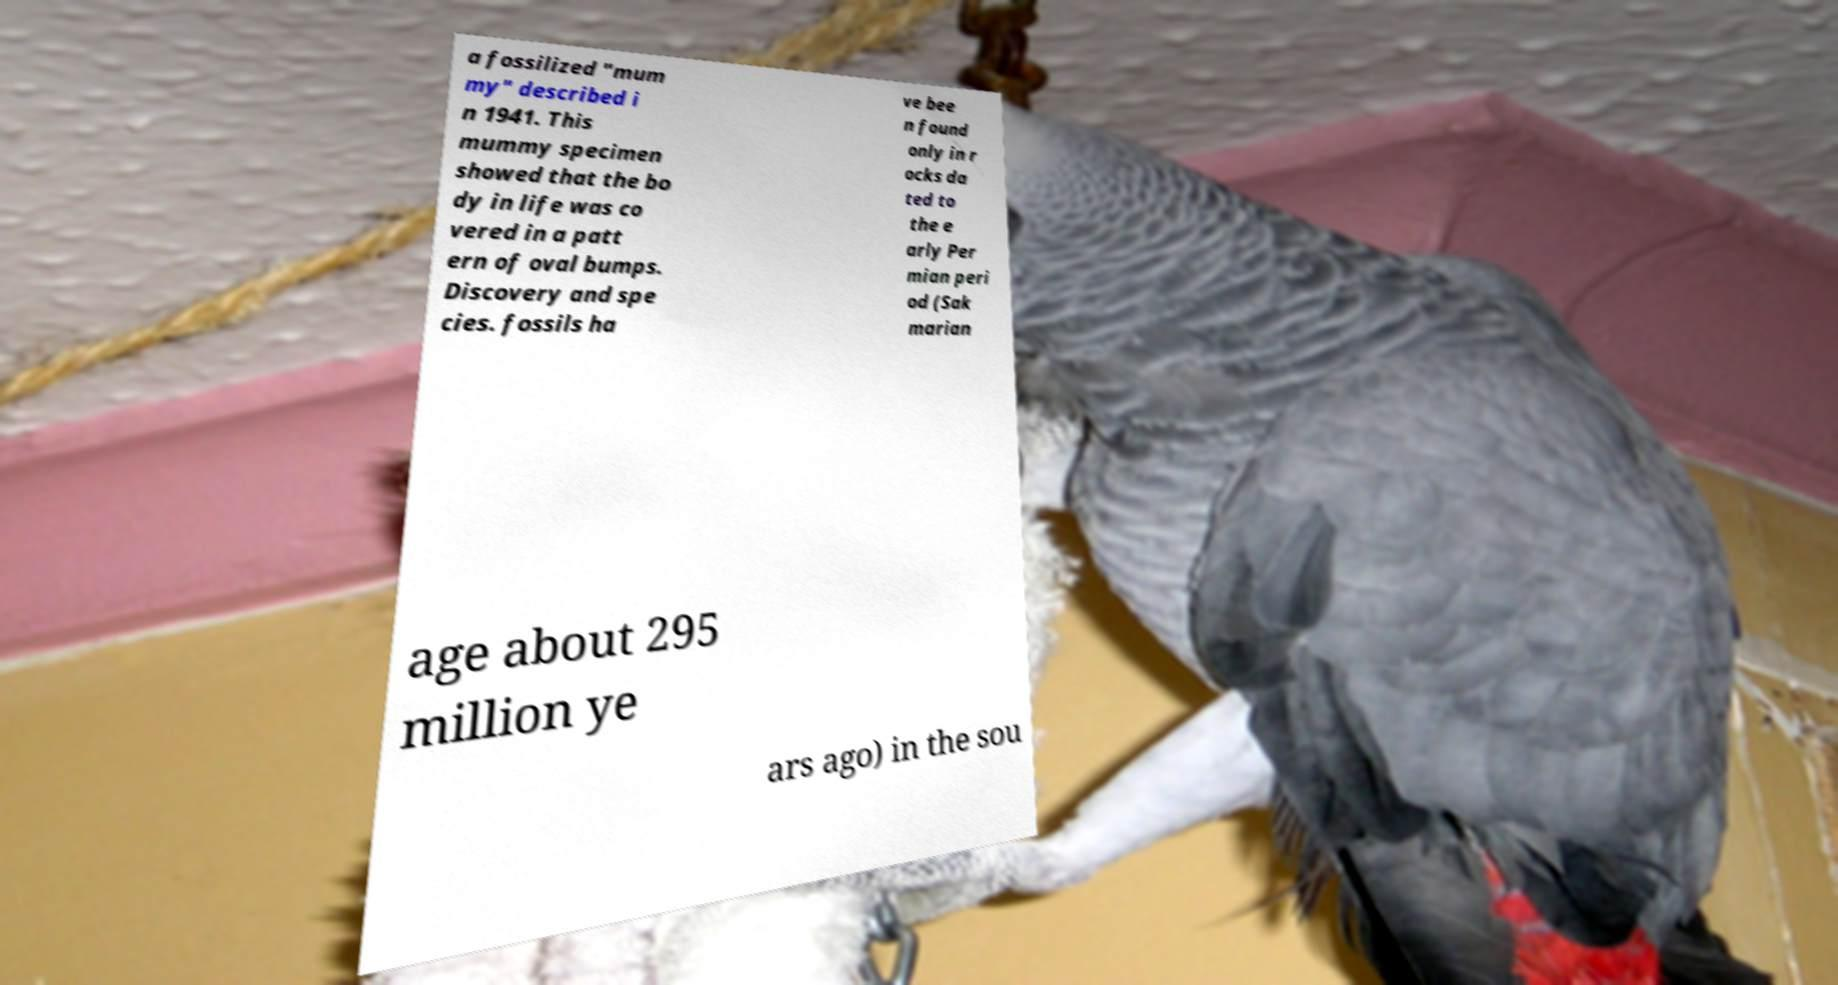Can you read and provide the text displayed in the image?This photo seems to have some interesting text. Can you extract and type it out for me? a fossilized "mum my" described i n 1941. This mummy specimen showed that the bo dy in life was co vered in a patt ern of oval bumps. Discovery and spe cies. fossils ha ve bee n found only in r ocks da ted to the e arly Per mian peri od (Sak marian age about 295 million ye ars ago) in the sou 